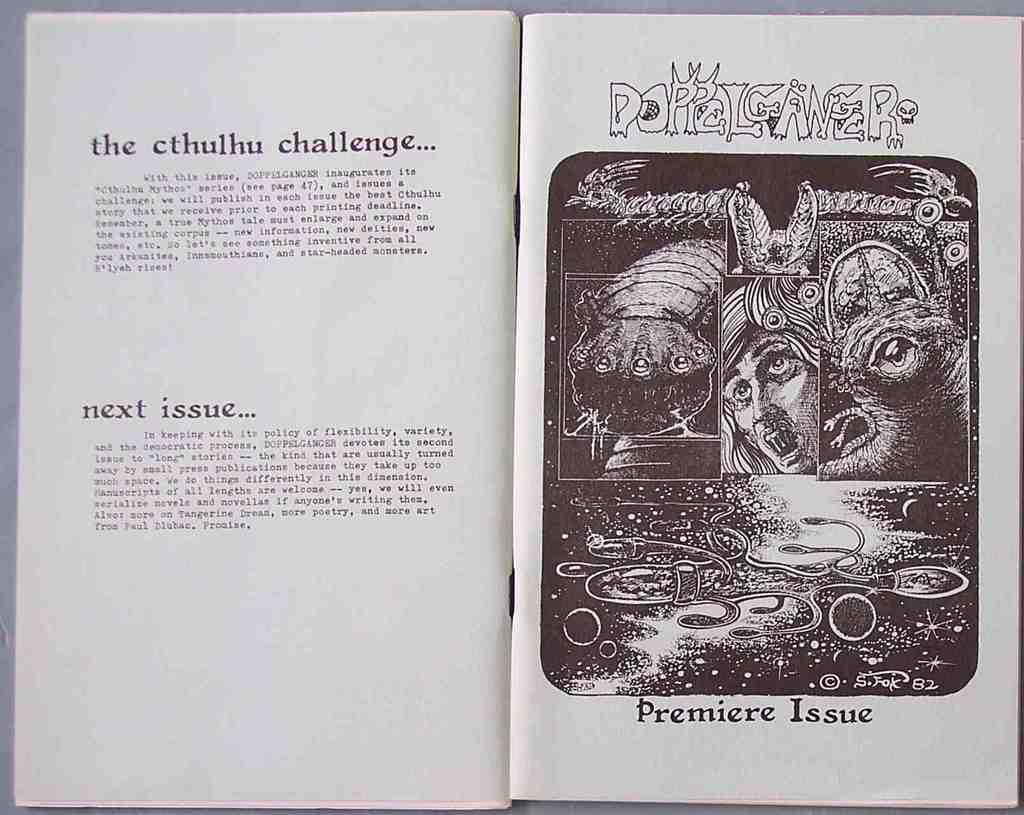Provide a one-sentence caption for the provided image. A book is open with a picture and the designation of premiere issue below it. 